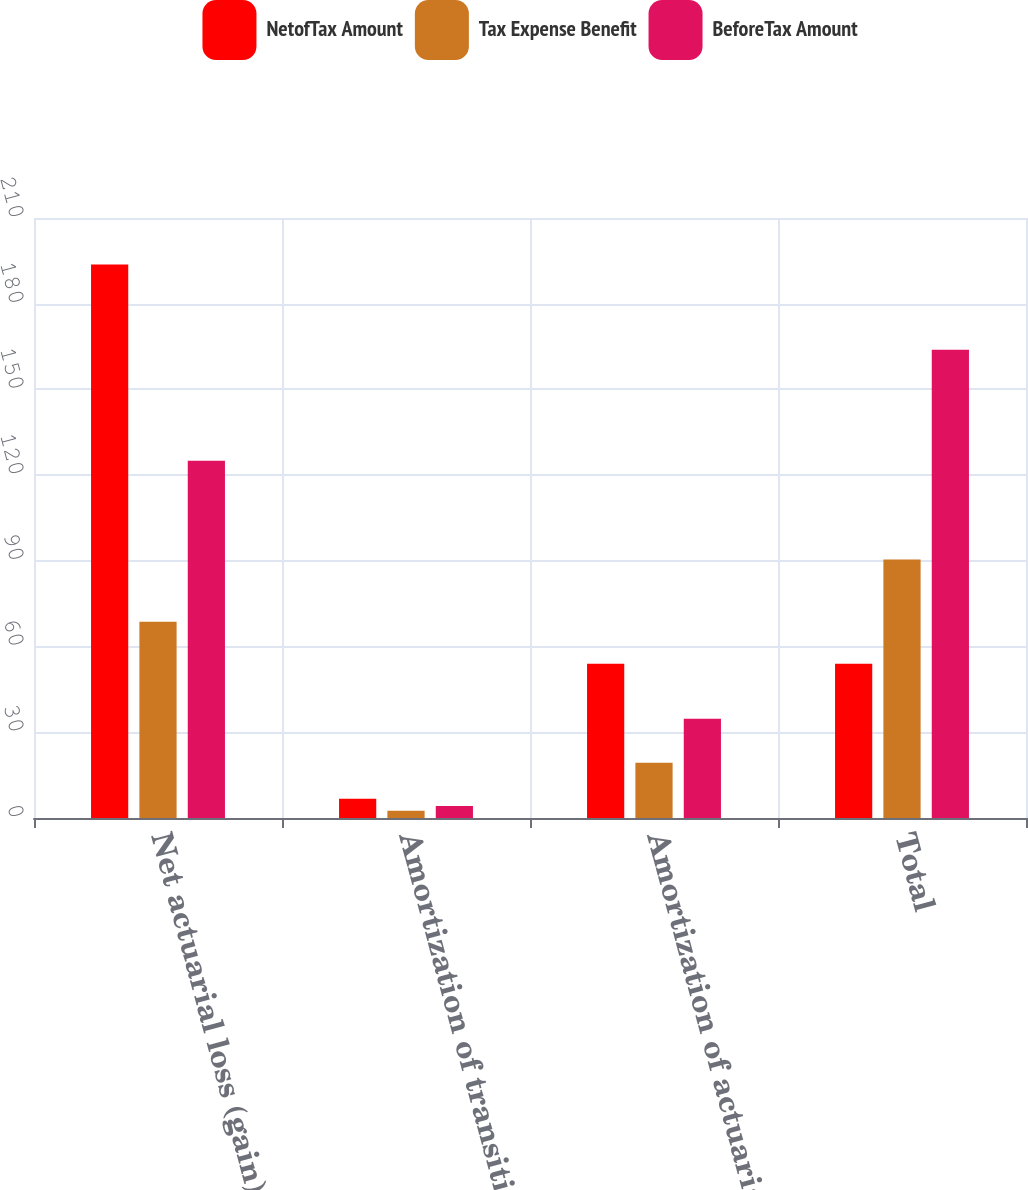Convert chart to OTSL. <chart><loc_0><loc_0><loc_500><loc_500><stacked_bar_chart><ecel><fcel>Net actuarial loss (gain)<fcel>Amortization of transition &<fcel>Amortization of actuarial<fcel>Total<nl><fcel>NetofTax Amount<fcel>193.7<fcel>6.7<fcel>54<fcel>54<nl><fcel>Tax Expense Benefit<fcel>68.7<fcel>2.5<fcel>19.3<fcel>90.5<nl><fcel>BeforeTax Amount<fcel>125<fcel>4.2<fcel>34.7<fcel>163.9<nl></chart> 